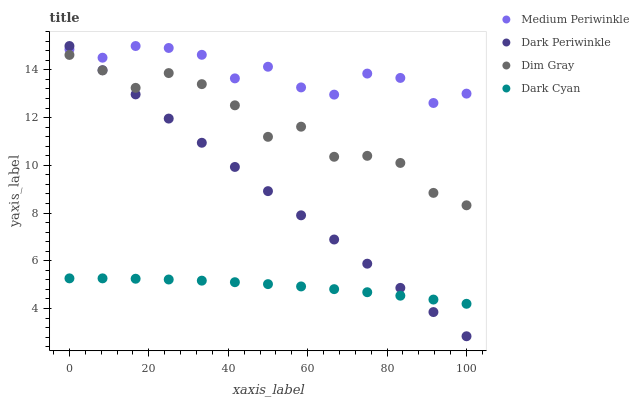Does Dark Cyan have the minimum area under the curve?
Answer yes or no. Yes. Does Medium Periwinkle have the maximum area under the curve?
Answer yes or no. Yes. Does Dim Gray have the minimum area under the curve?
Answer yes or no. No. Does Dim Gray have the maximum area under the curve?
Answer yes or no. No. Is Dark Periwinkle the smoothest?
Answer yes or no. Yes. Is Medium Periwinkle the roughest?
Answer yes or no. Yes. Is Dim Gray the smoothest?
Answer yes or no. No. Is Dim Gray the roughest?
Answer yes or no. No. Does Dark Periwinkle have the lowest value?
Answer yes or no. Yes. Does Dim Gray have the lowest value?
Answer yes or no. No. Does Dark Periwinkle have the highest value?
Answer yes or no. Yes. Does Dim Gray have the highest value?
Answer yes or no. No. Is Dark Cyan less than Medium Periwinkle?
Answer yes or no. Yes. Is Medium Periwinkle greater than Dark Cyan?
Answer yes or no. Yes. Does Dim Gray intersect Dark Periwinkle?
Answer yes or no. Yes. Is Dim Gray less than Dark Periwinkle?
Answer yes or no. No. Is Dim Gray greater than Dark Periwinkle?
Answer yes or no. No. Does Dark Cyan intersect Medium Periwinkle?
Answer yes or no. No. 